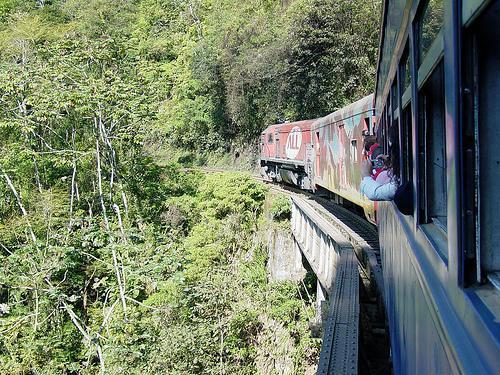How many train cars can be seen?
Give a very brief answer. 3. How many railway cars are red?
Give a very brief answer. 1. 